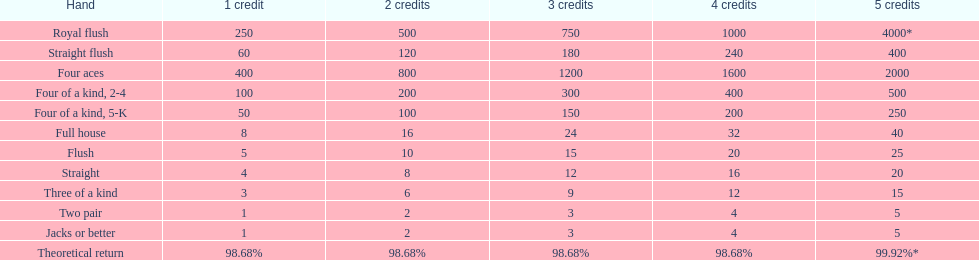What are the top 5 most excellent hand varieties for winning? Royal flush, Straight flush, Four aces, Four of a kind, 2-4, Four of a kind, 5-K. Among those 5, which of those hands are four of a kind? Four of a kind, 2-4, Four of a kind, 5-K. Of those 2 hands, which is the finest type of four of a kind for winning? Four of a kind, 2-4. 